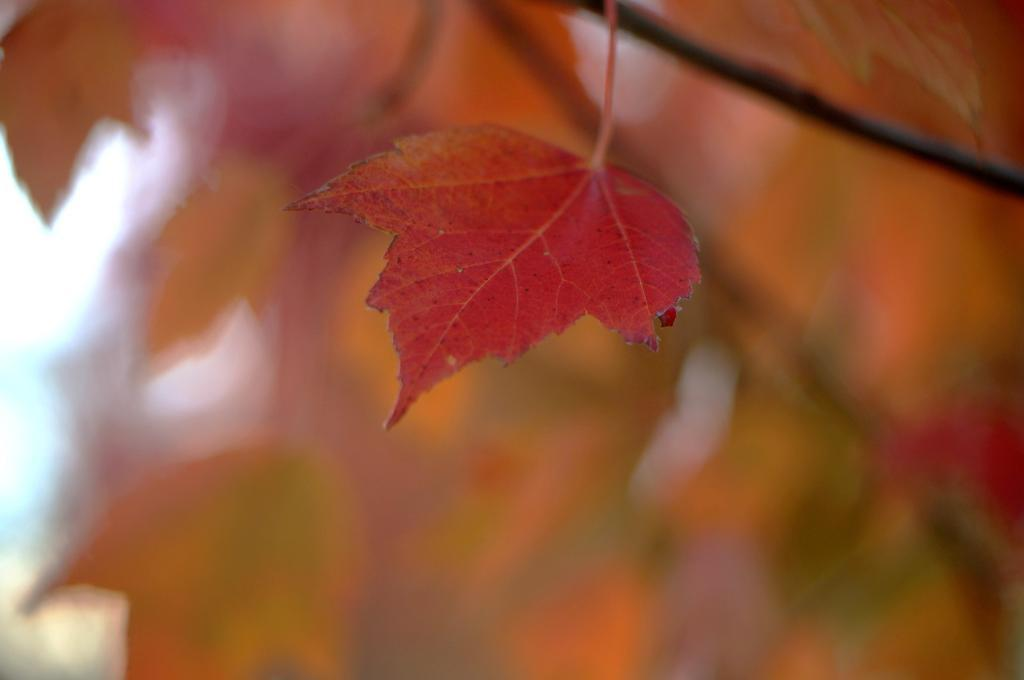What is the main subject of the image? There is a leaf in the image. Can you describe the background of the image? The background of the image is blurred. What type of fuel is being used in the oven in the image? There is no oven present in the image; it only features a leaf and a blurred background. Can you tell me how the grandfather is interacting with the leaf in the image? There is no person, including a grandfather, present in the image; it only features a leaf and a blurred background. 